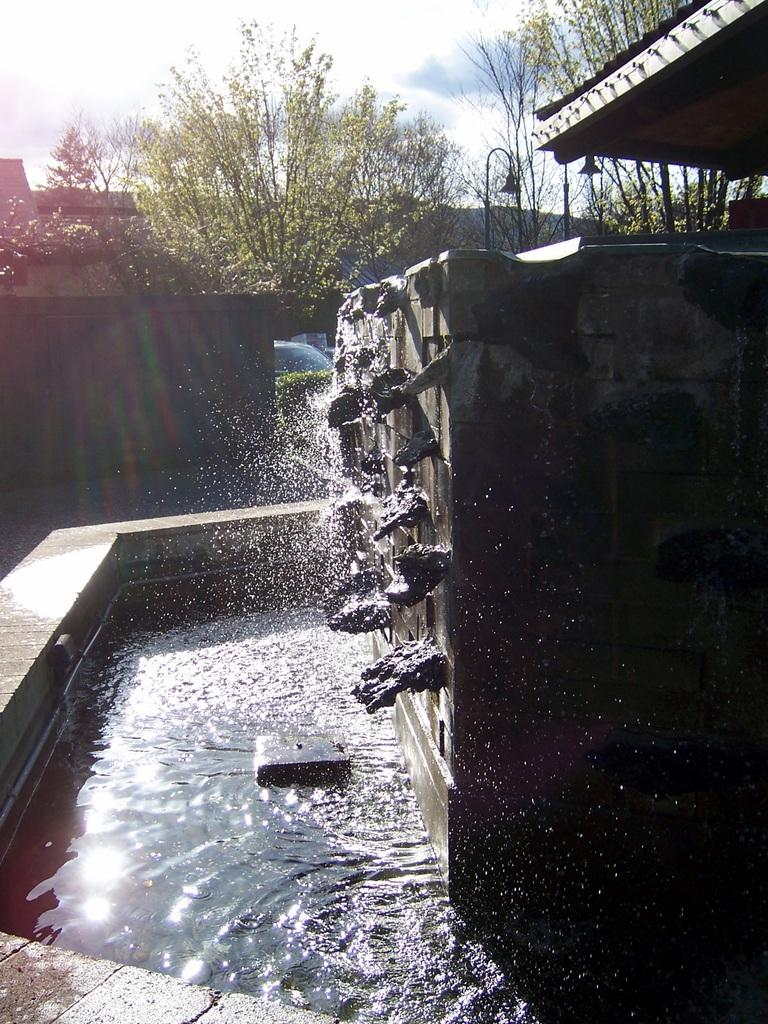What is the source of the water falling in the image? Water is falling from something in the image, but the specific source is not mentioned. What type of natural environment can be seen in the background of the image? There are trees in the background of the image, indicating a natural setting. What else is visible in the background of the image? The sky and a house are visible in the background of the image. How does the hammer maintain its balance while slipping in the image? There is no hammer or any indication of slipping in the image. 